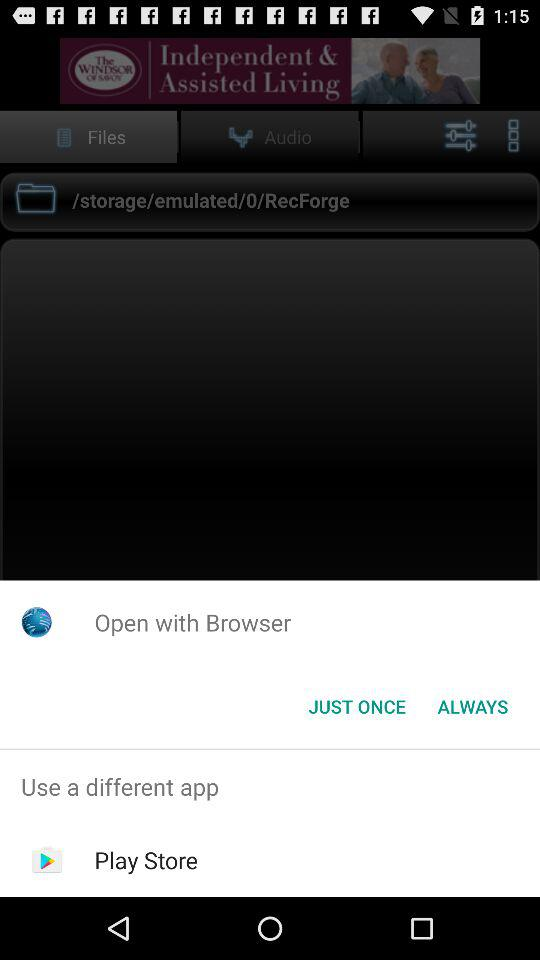Through what application can be open? You can open it with a browser. 